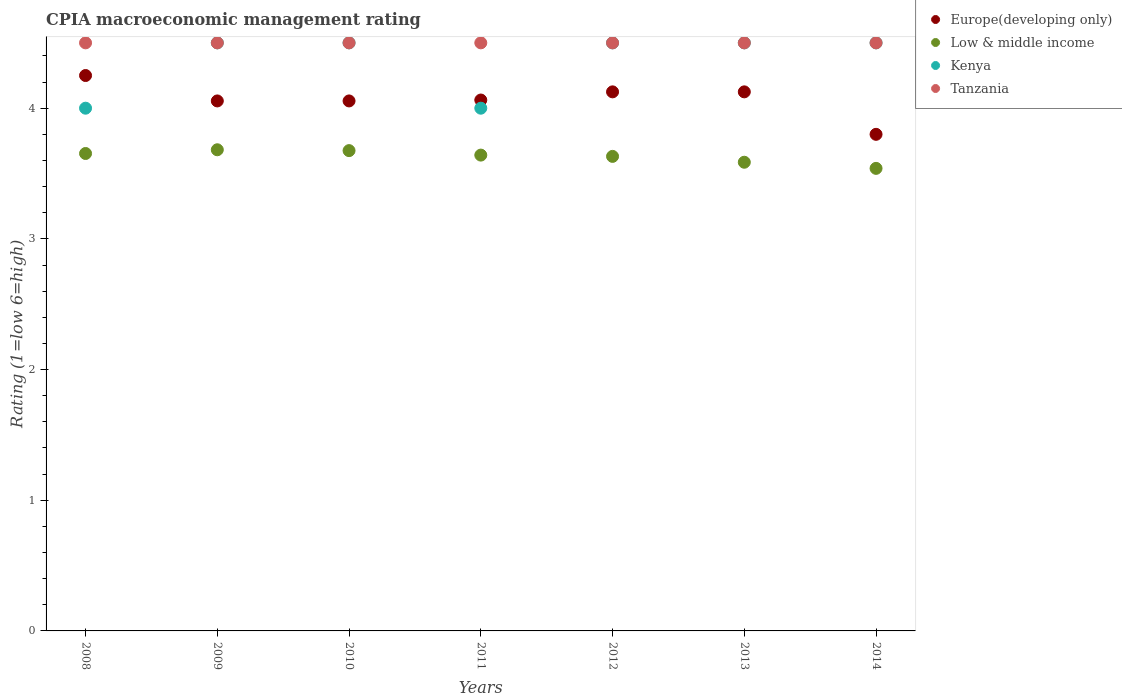What is the CPIA rating in Low & middle income in 2014?
Provide a succinct answer. 3.54. Across all years, what is the maximum CPIA rating in Europe(developing only)?
Offer a terse response. 4.25. In which year was the CPIA rating in Europe(developing only) minimum?
Keep it short and to the point. 2014. What is the total CPIA rating in Low & middle income in the graph?
Give a very brief answer. 25.41. What is the difference between the CPIA rating in Europe(developing only) in 2009 and that in 2014?
Give a very brief answer. 0.26. What is the difference between the CPIA rating in Low & middle income in 2011 and the CPIA rating in Kenya in 2008?
Keep it short and to the point. -0.36. What is the average CPIA rating in Low & middle income per year?
Keep it short and to the point. 3.63. In the year 2009, what is the difference between the CPIA rating in Europe(developing only) and CPIA rating in Kenya?
Provide a succinct answer. -0.44. In how many years, is the CPIA rating in Low & middle income greater than 1?
Your answer should be very brief. 7. What is the ratio of the CPIA rating in Tanzania in 2008 to that in 2010?
Give a very brief answer. 1. Is the difference between the CPIA rating in Europe(developing only) in 2013 and 2014 greater than the difference between the CPIA rating in Kenya in 2013 and 2014?
Your answer should be very brief. Yes. What is the difference between the highest and the second highest CPIA rating in Kenya?
Offer a terse response. 0. What is the difference between the highest and the lowest CPIA rating in Low & middle income?
Ensure brevity in your answer.  0.14. Is it the case that in every year, the sum of the CPIA rating in Kenya and CPIA rating in Europe(developing only)  is greater than the sum of CPIA rating in Tanzania and CPIA rating in Low & middle income?
Keep it short and to the point. No. Is it the case that in every year, the sum of the CPIA rating in Kenya and CPIA rating in Tanzania  is greater than the CPIA rating in Low & middle income?
Provide a short and direct response. Yes. Is the CPIA rating in Kenya strictly greater than the CPIA rating in Low & middle income over the years?
Provide a short and direct response. Yes. Is the CPIA rating in Tanzania strictly less than the CPIA rating in Low & middle income over the years?
Your response must be concise. No. What is the difference between two consecutive major ticks on the Y-axis?
Give a very brief answer. 1. Does the graph contain any zero values?
Your answer should be very brief. No. Does the graph contain grids?
Give a very brief answer. No. Where does the legend appear in the graph?
Keep it short and to the point. Top right. How many legend labels are there?
Give a very brief answer. 4. How are the legend labels stacked?
Provide a succinct answer. Vertical. What is the title of the graph?
Offer a terse response. CPIA macroeconomic management rating. Does "Cambodia" appear as one of the legend labels in the graph?
Give a very brief answer. No. What is the Rating (1=low 6=high) of Europe(developing only) in 2008?
Give a very brief answer. 4.25. What is the Rating (1=low 6=high) in Low & middle income in 2008?
Your answer should be compact. 3.65. What is the Rating (1=low 6=high) in Kenya in 2008?
Offer a terse response. 4. What is the Rating (1=low 6=high) of Europe(developing only) in 2009?
Make the answer very short. 4.06. What is the Rating (1=low 6=high) in Low & middle income in 2009?
Make the answer very short. 3.68. What is the Rating (1=low 6=high) of Kenya in 2009?
Keep it short and to the point. 4.5. What is the Rating (1=low 6=high) in Europe(developing only) in 2010?
Your answer should be very brief. 4.06. What is the Rating (1=low 6=high) of Low & middle income in 2010?
Offer a very short reply. 3.68. What is the Rating (1=low 6=high) of Europe(developing only) in 2011?
Your response must be concise. 4.06. What is the Rating (1=low 6=high) in Low & middle income in 2011?
Provide a succinct answer. 3.64. What is the Rating (1=low 6=high) in Kenya in 2011?
Your response must be concise. 4. What is the Rating (1=low 6=high) of Europe(developing only) in 2012?
Offer a very short reply. 4.12. What is the Rating (1=low 6=high) of Low & middle income in 2012?
Offer a very short reply. 3.63. What is the Rating (1=low 6=high) in Kenya in 2012?
Your answer should be very brief. 4.5. What is the Rating (1=low 6=high) of Tanzania in 2012?
Your answer should be very brief. 4.5. What is the Rating (1=low 6=high) in Europe(developing only) in 2013?
Your answer should be compact. 4.12. What is the Rating (1=low 6=high) in Low & middle income in 2013?
Your response must be concise. 3.59. What is the Rating (1=low 6=high) of Tanzania in 2013?
Your answer should be very brief. 4.5. What is the Rating (1=low 6=high) in Europe(developing only) in 2014?
Your answer should be compact. 3.8. What is the Rating (1=low 6=high) of Low & middle income in 2014?
Offer a terse response. 3.54. What is the Rating (1=low 6=high) of Kenya in 2014?
Provide a short and direct response. 4.5. What is the Rating (1=low 6=high) of Tanzania in 2014?
Make the answer very short. 4.5. Across all years, what is the maximum Rating (1=low 6=high) in Europe(developing only)?
Provide a short and direct response. 4.25. Across all years, what is the maximum Rating (1=low 6=high) in Low & middle income?
Give a very brief answer. 3.68. Across all years, what is the maximum Rating (1=low 6=high) in Tanzania?
Make the answer very short. 4.5. Across all years, what is the minimum Rating (1=low 6=high) of Low & middle income?
Provide a short and direct response. 3.54. Across all years, what is the minimum Rating (1=low 6=high) of Tanzania?
Give a very brief answer. 4.5. What is the total Rating (1=low 6=high) of Europe(developing only) in the graph?
Make the answer very short. 28.47. What is the total Rating (1=low 6=high) of Low & middle income in the graph?
Provide a succinct answer. 25.41. What is the total Rating (1=low 6=high) in Kenya in the graph?
Give a very brief answer. 30.5. What is the total Rating (1=low 6=high) in Tanzania in the graph?
Provide a short and direct response. 31.5. What is the difference between the Rating (1=low 6=high) of Europe(developing only) in 2008 and that in 2009?
Offer a very short reply. 0.19. What is the difference between the Rating (1=low 6=high) in Low & middle income in 2008 and that in 2009?
Offer a very short reply. -0.03. What is the difference between the Rating (1=low 6=high) of Europe(developing only) in 2008 and that in 2010?
Keep it short and to the point. 0.19. What is the difference between the Rating (1=low 6=high) in Low & middle income in 2008 and that in 2010?
Your response must be concise. -0.02. What is the difference between the Rating (1=low 6=high) of Kenya in 2008 and that in 2010?
Your answer should be compact. -0.5. What is the difference between the Rating (1=low 6=high) of Tanzania in 2008 and that in 2010?
Give a very brief answer. 0. What is the difference between the Rating (1=low 6=high) of Europe(developing only) in 2008 and that in 2011?
Offer a terse response. 0.19. What is the difference between the Rating (1=low 6=high) of Low & middle income in 2008 and that in 2011?
Keep it short and to the point. 0.01. What is the difference between the Rating (1=low 6=high) of Kenya in 2008 and that in 2011?
Your answer should be very brief. 0. What is the difference between the Rating (1=low 6=high) in Europe(developing only) in 2008 and that in 2012?
Keep it short and to the point. 0.12. What is the difference between the Rating (1=low 6=high) of Low & middle income in 2008 and that in 2012?
Your answer should be very brief. 0.02. What is the difference between the Rating (1=low 6=high) of Kenya in 2008 and that in 2012?
Offer a very short reply. -0.5. What is the difference between the Rating (1=low 6=high) in Europe(developing only) in 2008 and that in 2013?
Ensure brevity in your answer.  0.12. What is the difference between the Rating (1=low 6=high) of Low & middle income in 2008 and that in 2013?
Offer a terse response. 0.07. What is the difference between the Rating (1=low 6=high) of Europe(developing only) in 2008 and that in 2014?
Your response must be concise. 0.45. What is the difference between the Rating (1=low 6=high) in Low & middle income in 2008 and that in 2014?
Offer a terse response. 0.11. What is the difference between the Rating (1=low 6=high) in Kenya in 2008 and that in 2014?
Offer a terse response. -0.5. What is the difference between the Rating (1=low 6=high) of Europe(developing only) in 2009 and that in 2010?
Your answer should be very brief. 0. What is the difference between the Rating (1=low 6=high) of Low & middle income in 2009 and that in 2010?
Offer a terse response. 0.01. What is the difference between the Rating (1=low 6=high) of Kenya in 2009 and that in 2010?
Provide a short and direct response. 0. What is the difference between the Rating (1=low 6=high) of Europe(developing only) in 2009 and that in 2011?
Make the answer very short. -0.01. What is the difference between the Rating (1=low 6=high) in Low & middle income in 2009 and that in 2011?
Your response must be concise. 0.04. What is the difference between the Rating (1=low 6=high) of Kenya in 2009 and that in 2011?
Provide a short and direct response. 0.5. What is the difference between the Rating (1=low 6=high) of Tanzania in 2009 and that in 2011?
Provide a succinct answer. 0. What is the difference between the Rating (1=low 6=high) in Europe(developing only) in 2009 and that in 2012?
Ensure brevity in your answer.  -0.07. What is the difference between the Rating (1=low 6=high) of Low & middle income in 2009 and that in 2012?
Give a very brief answer. 0.05. What is the difference between the Rating (1=low 6=high) in Europe(developing only) in 2009 and that in 2013?
Your answer should be very brief. -0.07. What is the difference between the Rating (1=low 6=high) in Low & middle income in 2009 and that in 2013?
Provide a short and direct response. 0.1. What is the difference between the Rating (1=low 6=high) of Europe(developing only) in 2009 and that in 2014?
Keep it short and to the point. 0.26. What is the difference between the Rating (1=low 6=high) in Low & middle income in 2009 and that in 2014?
Keep it short and to the point. 0.14. What is the difference between the Rating (1=low 6=high) of Europe(developing only) in 2010 and that in 2011?
Your response must be concise. -0.01. What is the difference between the Rating (1=low 6=high) in Low & middle income in 2010 and that in 2011?
Your answer should be compact. 0.03. What is the difference between the Rating (1=low 6=high) in Europe(developing only) in 2010 and that in 2012?
Give a very brief answer. -0.07. What is the difference between the Rating (1=low 6=high) of Low & middle income in 2010 and that in 2012?
Your answer should be compact. 0.04. What is the difference between the Rating (1=low 6=high) in Tanzania in 2010 and that in 2012?
Offer a terse response. 0. What is the difference between the Rating (1=low 6=high) of Europe(developing only) in 2010 and that in 2013?
Offer a very short reply. -0.07. What is the difference between the Rating (1=low 6=high) of Low & middle income in 2010 and that in 2013?
Provide a succinct answer. 0.09. What is the difference between the Rating (1=low 6=high) in Kenya in 2010 and that in 2013?
Give a very brief answer. 0. What is the difference between the Rating (1=low 6=high) in Tanzania in 2010 and that in 2013?
Keep it short and to the point. 0. What is the difference between the Rating (1=low 6=high) of Europe(developing only) in 2010 and that in 2014?
Provide a short and direct response. 0.26. What is the difference between the Rating (1=low 6=high) of Low & middle income in 2010 and that in 2014?
Keep it short and to the point. 0.14. What is the difference between the Rating (1=low 6=high) of Tanzania in 2010 and that in 2014?
Ensure brevity in your answer.  0. What is the difference between the Rating (1=low 6=high) in Europe(developing only) in 2011 and that in 2012?
Provide a short and direct response. -0.06. What is the difference between the Rating (1=low 6=high) in Low & middle income in 2011 and that in 2012?
Provide a short and direct response. 0.01. What is the difference between the Rating (1=low 6=high) in Tanzania in 2011 and that in 2012?
Ensure brevity in your answer.  0. What is the difference between the Rating (1=low 6=high) of Europe(developing only) in 2011 and that in 2013?
Offer a very short reply. -0.06. What is the difference between the Rating (1=low 6=high) of Low & middle income in 2011 and that in 2013?
Provide a short and direct response. 0.05. What is the difference between the Rating (1=low 6=high) of Europe(developing only) in 2011 and that in 2014?
Ensure brevity in your answer.  0.26. What is the difference between the Rating (1=low 6=high) of Low & middle income in 2011 and that in 2014?
Make the answer very short. 0.1. What is the difference between the Rating (1=low 6=high) of Kenya in 2011 and that in 2014?
Provide a succinct answer. -0.5. What is the difference between the Rating (1=low 6=high) in Tanzania in 2011 and that in 2014?
Provide a short and direct response. 0. What is the difference between the Rating (1=low 6=high) in Low & middle income in 2012 and that in 2013?
Your answer should be compact. 0.04. What is the difference between the Rating (1=low 6=high) in Kenya in 2012 and that in 2013?
Ensure brevity in your answer.  0. What is the difference between the Rating (1=low 6=high) of Tanzania in 2012 and that in 2013?
Make the answer very short. 0. What is the difference between the Rating (1=low 6=high) of Europe(developing only) in 2012 and that in 2014?
Your response must be concise. 0.33. What is the difference between the Rating (1=low 6=high) of Low & middle income in 2012 and that in 2014?
Provide a succinct answer. 0.09. What is the difference between the Rating (1=low 6=high) of Kenya in 2012 and that in 2014?
Offer a terse response. 0. What is the difference between the Rating (1=low 6=high) in Tanzania in 2012 and that in 2014?
Make the answer very short. 0. What is the difference between the Rating (1=low 6=high) in Europe(developing only) in 2013 and that in 2014?
Provide a succinct answer. 0.33. What is the difference between the Rating (1=low 6=high) of Low & middle income in 2013 and that in 2014?
Offer a terse response. 0.05. What is the difference between the Rating (1=low 6=high) of Kenya in 2013 and that in 2014?
Make the answer very short. 0. What is the difference between the Rating (1=low 6=high) in Tanzania in 2013 and that in 2014?
Provide a succinct answer. 0. What is the difference between the Rating (1=low 6=high) of Europe(developing only) in 2008 and the Rating (1=low 6=high) of Low & middle income in 2009?
Keep it short and to the point. 0.57. What is the difference between the Rating (1=low 6=high) of Europe(developing only) in 2008 and the Rating (1=low 6=high) of Kenya in 2009?
Ensure brevity in your answer.  -0.25. What is the difference between the Rating (1=low 6=high) of Europe(developing only) in 2008 and the Rating (1=low 6=high) of Tanzania in 2009?
Offer a terse response. -0.25. What is the difference between the Rating (1=low 6=high) in Low & middle income in 2008 and the Rating (1=low 6=high) in Kenya in 2009?
Make the answer very short. -0.85. What is the difference between the Rating (1=low 6=high) of Low & middle income in 2008 and the Rating (1=low 6=high) of Tanzania in 2009?
Provide a succinct answer. -0.85. What is the difference between the Rating (1=low 6=high) of Kenya in 2008 and the Rating (1=low 6=high) of Tanzania in 2009?
Provide a short and direct response. -0.5. What is the difference between the Rating (1=low 6=high) in Europe(developing only) in 2008 and the Rating (1=low 6=high) in Low & middle income in 2010?
Your answer should be very brief. 0.57. What is the difference between the Rating (1=low 6=high) in Europe(developing only) in 2008 and the Rating (1=low 6=high) in Tanzania in 2010?
Offer a terse response. -0.25. What is the difference between the Rating (1=low 6=high) of Low & middle income in 2008 and the Rating (1=low 6=high) of Kenya in 2010?
Provide a short and direct response. -0.85. What is the difference between the Rating (1=low 6=high) in Low & middle income in 2008 and the Rating (1=low 6=high) in Tanzania in 2010?
Your answer should be compact. -0.85. What is the difference between the Rating (1=low 6=high) in Kenya in 2008 and the Rating (1=low 6=high) in Tanzania in 2010?
Your answer should be very brief. -0.5. What is the difference between the Rating (1=low 6=high) of Europe(developing only) in 2008 and the Rating (1=low 6=high) of Low & middle income in 2011?
Give a very brief answer. 0.61. What is the difference between the Rating (1=low 6=high) of Europe(developing only) in 2008 and the Rating (1=low 6=high) of Tanzania in 2011?
Provide a succinct answer. -0.25. What is the difference between the Rating (1=low 6=high) in Low & middle income in 2008 and the Rating (1=low 6=high) in Kenya in 2011?
Offer a terse response. -0.35. What is the difference between the Rating (1=low 6=high) in Low & middle income in 2008 and the Rating (1=low 6=high) in Tanzania in 2011?
Give a very brief answer. -0.85. What is the difference between the Rating (1=low 6=high) of Europe(developing only) in 2008 and the Rating (1=low 6=high) of Low & middle income in 2012?
Offer a very short reply. 0.62. What is the difference between the Rating (1=low 6=high) of Europe(developing only) in 2008 and the Rating (1=low 6=high) of Tanzania in 2012?
Offer a very short reply. -0.25. What is the difference between the Rating (1=low 6=high) of Low & middle income in 2008 and the Rating (1=low 6=high) of Kenya in 2012?
Provide a succinct answer. -0.85. What is the difference between the Rating (1=low 6=high) in Low & middle income in 2008 and the Rating (1=low 6=high) in Tanzania in 2012?
Offer a terse response. -0.85. What is the difference between the Rating (1=low 6=high) of Kenya in 2008 and the Rating (1=low 6=high) of Tanzania in 2012?
Provide a succinct answer. -0.5. What is the difference between the Rating (1=low 6=high) of Europe(developing only) in 2008 and the Rating (1=low 6=high) of Low & middle income in 2013?
Ensure brevity in your answer.  0.66. What is the difference between the Rating (1=low 6=high) of Low & middle income in 2008 and the Rating (1=low 6=high) of Kenya in 2013?
Keep it short and to the point. -0.85. What is the difference between the Rating (1=low 6=high) of Low & middle income in 2008 and the Rating (1=low 6=high) of Tanzania in 2013?
Provide a succinct answer. -0.85. What is the difference between the Rating (1=low 6=high) of Europe(developing only) in 2008 and the Rating (1=low 6=high) of Low & middle income in 2014?
Provide a succinct answer. 0.71. What is the difference between the Rating (1=low 6=high) of Europe(developing only) in 2008 and the Rating (1=low 6=high) of Tanzania in 2014?
Give a very brief answer. -0.25. What is the difference between the Rating (1=low 6=high) of Low & middle income in 2008 and the Rating (1=low 6=high) of Kenya in 2014?
Provide a succinct answer. -0.85. What is the difference between the Rating (1=low 6=high) of Low & middle income in 2008 and the Rating (1=low 6=high) of Tanzania in 2014?
Offer a very short reply. -0.85. What is the difference between the Rating (1=low 6=high) in Kenya in 2008 and the Rating (1=low 6=high) in Tanzania in 2014?
Your response must be concise. -0.5. What is the difference between the Rating (1=low 6=high) in Europe(developing only) in 2009 and the Rating (1=low 6=high) in Low & middle income in 2010?
Your response must be concise. 0.38. What is the difference between the Rating (1=low 6=high) in Europe(developing only) in 2009 and the Rating (1=low 6=high) in Kenya in 2010?
Keep it short and to the point. -0.44. What is the difference between the Rating (1=low 6=high) of Europe(developing only) in 2009 and the Rating (1=low 6=high) of Tanzania in 2010?
Make the answer very short. -0.44. What is the difference between the Rating (1=low 6=high) in Low & middle income in 2009 and the Rating (1=low 6=high) in Kenya in 2010?
Provide a succinct answer. -0.82. What is the difference between the Rating (1=low 6=high) in Low & middle income in 2009 and the Rating (1=low 6=high) in Tanzania in 2010?
Offer a very short reply. -0.82. What is the difference between the Rating (1=low 6=high) of Europe(developing only) in 2009 and the Rating (1=low 6=high) of Low & middle income in 2011?
Your response must be concise. 0.41. What is the difference between the Rating (1=low 6=high) in Europe(developing only) in 2009 and the Rating (1=low 6=high) in Kenya in 2011?
Your answer should be compact. 0.06. What is the difference between the Rating (1=low 6=high) of Europe(developing only) in 2009 and the Rating (1=low 6=high) of Tanzania in 2011?
Your answer should be very brief. -0.44. What is the difference between the Rating (1=low 6=high) of Low & middle income in 2009 and the Rating (1=low 6=high) of Kenya in 2011?
Your answer should be compact. -0.32. What is the difference between the Rating (1=low 6=high) in Low & middle income in 2009 and the Rating (1=low 6=high) in Tanzania in 2011?
Keep it short and to the point. -0.82. What is the difference between the Rating (1=low 6=high) of Europe(developing only) in 2009 and the Rating (1=low 6=high) of Low & middle income in 2012?
Provide a short and direct response. 0.42. What is the difference between the Rating (1=low 6=high) in Europe(developing only) in 2009 and the Rating (1=low 6=high) in Kenya in 2012?
Your answer should be compact. -0.44. What is the difference between the Rating (1=low 6=high) in Europe(developing only) in 2009 and the Rating (1=low 6=high) in Tanzania in 2012?
Provide a short and direct response. -0.44. What is the difference between the Rating (1=low 6=high) of Low & middle income in 2009 and the Rating (1=low 6=high) of Kenya in 2012?
Your response must be concise. -0.82. What is the difference between the Rating (1=low 6=high) of Low & middle income in 2009 and the Rating (1=low 6=high) of Tanzania in 2012?
Make the answer very short. -0.82. What is the difference between the Rating (1=low 6=high) of Kenya in 2009 and the Rating (1=low 6=high) of Tanzania in 2012?
Your answer should be very brief. 0. What is the difference between the Rating (1=low 6=high) of Europe(developing only) in 2009 and the Rating (1=low 6=high) of Low & middle income in 2013?
Give a very brief answer. 0.47. What is the difference between the Rating (1=low 6=high) of Europe(developing only) in 2009 and the Rating (1=low 6=high) of Kenya in 2013?
Your answer should be compact. -0.44. What is the difference between the Rating (1=low 6=high) of Europe(developing only) in 2009 and the Rating (1=low 6=high) of Tanzania in 2013?
Give a very brief answer. -0.44. What is the difference between the Rating (1=low 6=high) of Low & middle income in 2009 and the Rating (1=low 6=high) of Kenya in 2013?
Your answer should be very brief. -0.82. What is the difference between the Rating (1=low 6=high) of Low & middle income in 2009 and the Rating (1=low 6=high) of Tanzania in 2013?
Make the answer very short. -0.82. What is the difference between the Rating (1=low 6=high) of Kenya in 2009 and the Rating (1=low 6=high) of Tanzania in 2013?
Your answer should be compact. 0. What is the difference between the Rating (1=low 6=high) of Europe(developing only) in 2009 and the Rating (1=low 6=high) of Low & middle income in 2014?
Your answer should be very brief. 0.52. What is the difference between the Rating (1=low 6=high) of Europe(developing only) in 2009 and the Rating (1=low 6=high) of Kenya in 2014?
Offer a very short reply. -0.44. What is the difference between the Rating (1=low 6=high) in Europe(developing only) in 2009 and the Rating (1=low 6=high) in Tanzania in 2014?
Provide a succinct answer. -0.44. What is the difference between the Rating (1=low 6=high) of Low & middle income in 2009 and the Rating (1=low 6=high) of Kenya in 2014?
Your response must be concise. -0.82. What is the difference between the Rating (1=low 6=high) of Low & middle income in 2009 and the Rating (1=low 6=high) of Tanzania in 2014?
Offer a terse response. -0.82. What is the difference between the Rating (1=low 6=high) in Kenya in 2009 and the Rating (1=low 6=high) in Tanzania in 2014?
Offer a very short reply. 0. What is the difference between the Rating (1=low 6=high) of Europe(developing only) in 2010 and the Rating (1=low 6=high) of Low & middle income in 2011?
Your response must be concise. 0.41. What is the difference between the Rating (1=low 6=high) in Europe(developing only) in 2010 and the Rating (1=low 6=high) in Kenya in 2011?
Offer a terse response. 0.06. What is the difference between the Rating (1=low 6=high) of Europe(developing only) in 2010 and the Rating (1=low 6=high) of Tanzania in 2011?
Offer a terse response. -0.44. What is the difference between the Rating (1=low 6=high) in Low & middle income in 2010 and the Rating (1=low 6=high) in Kenya in 2011?
Give a very brief answer. -0.32. What is the difference between the Rating (1=low 6=high) of Low & middle income in 2010 and the Rating (1=low 6=high) of Tanzania in 2011?
Keep it short and to the point. -0.82. What is the difference between the Rating (1=low 6=high) in Kenya in 2010 and the Rating (1=low 6=high) in Tanzania in 2011?
Provide a short and direct response. 0. What is the difference between the Rating (1=low 6=high) in Europe(developing only) in 2010 and the Rating (1=low 6=high) in Low & middle income in 2012?
Make the answer very short. 0.42. What is the difference between the Rating (1=low 6=high) in Europe(developing only) in 2010 and the Rating (1=low 6=high) in Kenya in 2012?
Your answer should be compact. -0.44. What is the difference between the Rating (1=low 6=high) in Europe(developing only) in 2010 and the Rating (1=low 6=high) in Tanzania in 2012?
Your response must be concise. -0.44. What is the difference between the Rating (1=low 6=high) of Low & middle income in 2010 and the Rating (1=low 6=high) of Kenya in 2012?
Your response must be concise. -0.82. What is the difference between the Rating (1=low 6=high) of Low & middle income in 2010 and the Rating (1=low 6=high) of Tanzania in 2012?
Make the answer very short. -0.82. What is the difference between the Rating (1=low 6=high) of Europe(developing only) in 2010 and the Rating (1=low 6=high) of Low & middle income in 2013?
Offer a very short reply. 0.47. What is the difference between the Rating (1=low 6=high) of Europe(developing only) in 2010 and the Rating (1=low 6=high) of Kenya in 2013?
Keep it short and to the point. -0.44. What is the difference between the Rating (1=low 6=high) of Europe(developing only) in 2010 and the Rating (1=low 6=high) of Tanzania in 2013?
Make the answer very short. -0.44. What is the difference between the Rating (1=low 6=high) in Low & middle income in 2010 and the Rating (1=low 6=high) in Kenya in 2013?
Offer a terse response. -0.82. What is the difference between the Rating (1=low 6=high) in Low & middle income in 2010 and the Rating (1=low 6=high) in Tanzania in 2013?
Keep it short and to the point. -0.82. What is the difference between the Rating (1=low 6=high) of Europe(developing only) in 2010 and the Rating (1=low 6=high) of Low & middle income in 2014?
Offer a terse response. 0.52. What is the difference between the Rating (1=low 6=high) in Europe(developing only) in 2010 and the Rating (1=low 6=high) in Kenya in 2014?
Your answer should be very brief. -0.44. What is the difference between the Rating (1=low 6=high) in Europe(developing only) in 2010 and the Rating (1=low 6=high) in Tanzania in 2014?
Your response must be concise. -0.44. What is the difference between the Rating (1=low 6=high) in Low & middle income in 2010 and the Rating (1=low 6=high) in Kenya in 2014?
Your answer should be very brief. -0.82. What is the difference between the Rating (1=low 6=high) in Low & middle income in 2010 and the Rating (1=low 6=high) in Tanzania in 2014?
Your response must be concise. -0.82. What is the difference between the Rating (1=low 6=high) in Europe(developing only) in 2011 and the Rating (1=low 6=high) in Low & middle income in 2012?
Keep it short and to the point. 0.43. What is the difference between the Rating (1=low 6=high) in Europe(developing only) in 2011 and the Rating (1=low 6=high) in Kenya in 2012?
Keep it short and to the point. -0.44. What is the difference between the Rating (1=low 6=high) of Europe(developing only) in 2011 and the Rating (1=low 6=high) of Tanzania in 2012?
Provide a succinct answer. -0.44. What is the difference between the Rating (1=low 6=high) in Low & middle income in 2011 and the Rating (1=low 6=high) in Kenya in 2012?
Provide a succinct answer. -0.86. What is the difference between the Rating (1=low 6=high) in Low & middle income in 2011 and the Rating (1=low 6=high) in Tanzania in 2012?
Your response must be concise. -0.86. What is the difference between the Rating (1=low 6=high) in Kenya in 2011 and the Rating (1=low 6=high) in Tanzania in 2012?
Provide a succinct answer. -0.5. What is the difference between the Rating (1=low 6=high) of Europe(developing only) in 2011 and the Rating (1=low 6=high) of Low & middle income in 2013?
Ensure brevity in your answer.  0.48. What is the difference between the Rating (1=low 6=high) of Europe(developing only) in 2011 and the Rating (1=low 6=high) of Kenya in 2013?
Your response must be concise. -0.44. What is the difference between the Rating (1=low 6=high) in Europe(developing only) in 2011 and the Rating (1=low 6=high) in Tanzania in 2013?
Provide a succinct answer. -0.44. What is the difference between the Rating (1=low 6=high) of Low & middle income in 2011 and the Rating (1=low 6=high) of Kenya in 2013?
Make the answer very short. -0.86. What is the difference between the Rating (1=low 6=high) of Low & middle income in 2011 and the Rating (1=low 6=high) of Tanzania in 2013?
Provide a short and direct response. -0.86. What is the difference between the Rating (1=low 6=high) of Europe(developing only) in 2011 and the Rating (1=low 6=high) of Low & middle income in 2014?
Ensure brevity in your answer.  0.52. What is the difference between the Rating (1=low 6=high) of Europe(developing only) in 2011 and the Rating (1=low 6=high) of Kenya in 2014?
Ensure brevity in your answer.  -0.44. What is the difference between the Rating (1=low 6=high) of Europe(developing only) in 2011 and the Rating (1=low 6=high) of Tanzania in 2014?
Your answer should be very brief. -0.44. What is the difference between the Rating (1=low 6=high) of Low & middle income in 2011 and the Rating (1=low 6=high) of Kenya in 2014?
Offer a terse response. -0.86. What is the difference between the Rating (1=low 6=high) of Low & middle income in 2011 and the Rating (1=low 6=high) of Tanzania in 2014?
Make the answer very short. -0.86. What is the difference between the Rating (1=low 6=high) of Kenya in 2011 and the Rating (1=low 6=high) of Tanzania in 2014?
Ensure brevity in your answer.  -0.5. What is the difference between the Rating (1=low 6=high) in Europe(developing only) in 2012 and the Rating (1=low 6=high) in Low & middle income in 2013?
Provide a short and direct response. 0.54. What is the difference between the Rating (1=low 6=high) in Europe(developing only) in 2012 and the Rating (1=low 6=high) in Kenya in 2013?
Ensure brevity in your answer.  -0.38. What is the difference between the Rating (1=low 6=high) of Europe(developing only) in 2012 and the Rating (1=low 6=high) of Tanzania in 2013?
Your answer should be compact. -0.38. What is the difference between the Rating (1=low 6=high) in Low & middle income in 2012 and the Rating (1=low 6=high) in Kenya in 2013?
Your response must be concise. -0.87. What is the difference between the Rating (1=low 6=high) in Low & middle income in 2012 and the Rating (1=low 6=high) in Tanzania in 2013?
Make the answer very short. -0.87. What is the difference between the Rating (1=low 6=high) of Europe(developing only) in 2012 and the Rating (1=low 6=high) of Low & middle income in 2014?
Provide a succinct answer. 0.59. What is the difference between the Rating (1=low 6=high) in Europe(developing only) in 2012 and the Rating (1=low 6=high) in Kenya in 2014?
Your answer should be very brief. -0.38. What is the difference between the Rating (1=low 6=high) in Europe(developing only) in 2012 and the Rating (1=low 6=high) in Tanzania in 2014?
Your answer should be very brief. -0.38. What is the difference between the Rating (1=low 6=high) of Low & middle income in 2012 and the Rating (1=low 6=high) of Kenya in 2014?
Provide a succinct answer. -0.87. What is the difference between the Rating (1=low 6=high) in Low & middle income in 2012 and the Rating (1=low 6=high) in Tanzania in 2014?
Your response must be concise. -0.87. What is the difference between the Rating (1=low 6=high) of Kenya in 2012 and the Rating (1=low 6=high) of Tanzania in 2014?
Make the answer very short. 0. What is the difference between the Rating (1=low 6=high) in Europe(developing only) in 2013 and the Rating (1=low 6=high) in Low & middle income in 2014?
Give a very brief answer. 0.59. What is the difference between the Rating (1=low 6=high) of Europe(developing only) in 2013 and the Rating (1=low 6=high) of Kenya in 2014?
Provide a succinct answer. -0.38. What is the difference between the Rating (1=low 6=high) in Europe(developing only) in 2013 and the Rating (1=low 6=high) in Tanzania in 2014?
Your response must be concise. -0.38. What is the difference between the Rating (1=low 6=high) in Low & middle income in 2013 and the Rating (1=low 6=high) in Kenya in 2014?
Keep it short and to the point. -0.91. What is the difference between the Rating (1=low 6=high) of Low & middle income in 2013 and the Rating (1=low 6=high) of Tanzania in 2014?
Offer a very short reply. -0.91. What is the difference between the Rating (1=low 6=high) of Kenya in 2013 and the Rating (1=low 6=high) of Tanzania in 2014?
Offer a terse response. 0. What is the average Rating (1=low 6=high) of Europe(developing only) per year?
Offer a very short reply. 4.07. What is the average Rating (1=low 6=high) of Low & middle income per year?
Your answer should be very brief. 3.63. What is the average Rating (1=low 6=high) of Kenya per year?
Keep it short and to the point. 4.36. What is the average Rating (1=low 6=high) in Tanzania per year?
Offer a very short reply. 4.5. In the year 2008, what is the difference between the Rating (1=low 6=high) of Europe(developing only) and Rating (1=low 6=high) of Low & middle income?
Offer a terse response. 0.6. In the year 2008, what is the difference between the Rating (1=low 6=high) in Europe(developing only) and Rating (1=low 6=high) in Tanzania?
Offer a very short reply. -0.25. In the year 2008, what is the difference between the Rating (1=low 6=high) of Low & middle income and Rating (1=low 6=high) of Kenya?
Offer a terse response. -0.35. In the year 2008, what is the difference between the Rating (1=low 6=high) in Low & middle income and Rating (1=low 6=high) in Tanzania?
Your answer should be compact. -0.85. In the year 2009, what is the difference between the Rating (1=low 6=high) in Europe(developing only) and Rating (1=low 6=high) in Low & middle income?
Provide a succinct answer. 0.37. In the year 2009, what is the difference between the Rating (1=low 6=high) of Europe(developing only) and Rating (1=low 6=high) of Kenya?
Your response must be concise. -0.44. In the year 2009, what is the difference between the Rating (1=low 6=high) of Europe(developing only) and Rating (1=low 6=high) of Tanzania?
Keep it short and to the point. -0.44. In the year 2009, what is the difference between the Rating (1=low 6=high) of Low & middle income and Rating (1=low 6=high) of Kenya?
Ensure brevity in your answer.  -0.82. In the year 2009, what is the difference between the Rating (1=low 6=high) of Low & middle income and Rating (1=low 6=high) of Tanzania?
Offer a very short reply. -0.82. In the year 2009, what is the difference between the Rating (1=low 6=high) of Kenya and Rating (1=low 6=high) of Tanzania?
Offer a terse response. 0. In the year 2010, what is the difference between the Rating (1=low 6=high) of Europe(developing only) and Rating (1=low 6=high) of Low & middle income?
Make the answer very short. 0.38. In the year 2010, what is the difference between the Rating (1=low 6=high) in Europe(developing only) and Rating (1=low 6=high) in Kenya?
Provide a succinct answer. -0.44. In the year 2010, what is the difference between the Rating (1=low 6=high) in Europe(developing only) and Rating (1=low 6=high) in Tanzania?
Ensure brevity in your answer.  -0.44. In the year 2010, what is the difference between the Rating (1=low 6=high) in Low & middle income and Rating (1=low 6=high) in Kenya?
Provide a short and direct response. -0.82. In the year 2010, what is the difference between the Rating (1=low 6=high) in Low & middle income and Rating (1=low 6=high) in Tanzania?
Ensure brevity in your answer.  -0.82. In the year 2010, what is the difference between the Rating (1=low 6=high) of Kenya and Rating (1=low 6=high) of Tanzania?
Provide a succinct answer. 0. In the year 2011, what is the difference between the Rating (1=low 6=high) of Europe(developing only) and Rating (1=low 6=high) of Low & middle income?
Offer a terse response. 0.42. In the year 2011, what is the difference between the Rating (1=low 6=high) of Europe(developing only) and Rating (1=low 6=high) of Kenya?
Give a very brief answer. 0.06. In the year 2011, what is the difference between the Rating (1=low 6=high) of Europe(developing only) and Rating (1=low 6=high) of Tanzania?
Provide a short and direct response. -0.44. In the year 2011, what is the difference between the Rating (1=low 6=high) in Low & middle income and Rating (1=low 6=high) in Kenya?
Keep it short and to the point. -0.36. In the year 2011, what is the difference between the Rating (1=low 6=high) of Low & middle income and Rating (1=low 6=high) of Tanzania?
Ensure brevity in your answer.  -0.86. In the year 2011, what is the difference between the Rating (1=low 6=high) in Kenya and Rating (1=low 6=high) in Tanzania?
Offer a terse response. -0.5. In the year 2012, what is the difference between the Rating (1=low 6=high) of Europe(developing only) and Rating (1=low 6=high) of Low & middle income?
Give a very brief answer. 0.49. In the year 2012, what is the difference between the Rating (1=low 6=high) of Europe(developing only) and Rating (1=low 6=high) of Kenya?
Provide a short and direct response. -0.38. In the year 2012, what is the difference between the Rating (1=low 6=high) of Europe(developing only) and Rating (1=low 6=high) of Tanzania?
Your answer should be compact. -0.38. In the year 2012, what is the difference between the Rating (1=low 6=high) in Low & middle income and Rating (1=low 6=high) in Kenya?
Ensure brevity in your answer.  -0.87. In the year 2012, what is the difference between the Rating (1=low 6=high) of Low & middle income and Rating (1=low 6=high) of Tanzania?
Provide a short and direct response. -0.87. In the year 2012, what is the difference between the Rating (1=low 6=high) in Kenya and Rating (1=low 6=high) in Tanzania?
Provide a succinct answer. 0. In the year 2013, what is the difference between the Rating (1=low 6=high) of Europe(developing only) and Rating (1=low 6=high) of Low & middle income?
Make the answer very short. 0.54. In the year 2013, what is the difference between the Rating (1=low 6=high) in Europe(developing only) and Rating (1=low 6=high) in Kenya?
Provide a short and direct response. -0.38. In the year 2013, what is the difference between the Rating (1=low 6=high) in Europe(developing only) and Rating (1=low 6=high) in Tanzania?
Your answer should be very brief. -0.38. In the year 2013, what is the difference between the Rating (1=low 6=high) in Low & middle income and Rating (1=low 6=high) in Kenya?
Give a very brief answer. -0.91. In the year 2013, what is the difference between the Rating (1=low 6=high) of Low & middle income and Rating (1=low 6=high) of Tanzania?
Your answer should be compact. -0.91. In the year 2014, what is the difference between the Rating (1=low 6=high) of Europe(developing only) and Rating (1=low 6=high) of Low & middle income?
Keep it short and to the point. 0.26. In the year 2014, what is the difference between the Rating (1=low 6=high) of Low & middle income and Rating (1=low 6=high) of Kenya?
Make the answer very short. -0.96. In the year 2014, what is the difference between the Rating (1=low 6=high) of Low & middle income and Rating (1=low 6=high) of Tanzania?
Your answer should be very brief. -0.96. In the year 2014, what is the difference between the Rating (1=low 6=high) in Kenya and Rating (1=low 6=high) in Tanzania?
Provide a short and direct response. 0. What is the ratio of the Rating (1=low 6=high) of Europe(developing only) in 2008 to that in 2009?
Offer a terse response. 1.05. What is the ratio of the Rating (1=low 6=high) in Low & middle income in 2008 to that in 2009?
Provide a succinct answer. 0.99. What is the ratio of the Rating (1=low 6=high) in Kenya in 2008 to that in 2009?
Offer a terse response. 0.89. What is the ratio of the Rating (1=low 6=high) of Tanzania in 2008 to that in 2009?
Offer a terse response. 1. What is the ratio of the Rating (1=low 6=high) in Europe(developing only) in 2008 to that in 2010?
Give a very brief answer. 1.05. What is the ratio of the Rating (1=low 6=high) of Kenya in 2008 to that in 2010?
Offer a very short reply. 0.89. What is the ratio of the Rating (1=low 6=high) of Europe(developing only) in 2008 to that in 2011?
Your response must be concise. 1.05. What is the ratio of the Rating (1=low 6=high) in Tanzania in 2008 to that in 2011?
Your answer should be very brief. 1. What is the ratio of the Rating (1=low 6=high) in Europe(developing only) in 2008 to that in 2012?
Provide a short and direct response. 1.03. What is the ratio of the Rating (1=low 6=high) in Europe(developing only) in 2008 to that in 2013?
Ensure brevity in your answer.  1.03. What is the ratio of the Rating (1=low 6=high) in Low & middle income in 2008 to that in 2013?
Give a very brief answer. 1.02. What is the ratio of the Rating (1=low 6=high) in Kenya in 2008 to that in 2013?
Your answer should be compact. 0.89. What is the ratio of the Rating (1=low 6=high) in Europe(developing only) in 2008 to that in 2014?
Provide a short and direct response. 1.12. What is the ratio of the Rating (1=low 6=high) in Low & middle income in 2008 to that in 2014?
Ensure brevity in your answer.  1.03. What is the ratio of the Rating (1=low 6=high) in Kenya in 2008 to that in 2014?
Your answer should be compact. 0.89. What is the ratio of the Rating (1=low 6=high) of Kenya in 2009 to that in 2010?
Offer a terse response. 1. What is the ratio of the Rating (1=low 6=high) of Tanzania in 2009 to that in 2010?
Offer a very short reply. 1. What is the ratio of the Rating (1=low 6=high) of Europe(developing only) in 2009 to that in 2011?
Offer a very short reply. 1. What is the ratio of the Rating (1=low 6=high) in Low & middle income in 2009 to that in 2011?
Provide a short and direct response. 1.01. What is the ratio of the Rating (1=low 6=high) of Europe(developing only) in 2009 to that in 2012?
Your answer should be compact. 0.98. What is the ratio of the Rating (1=low 6=high) of Low & middle income in 2009 to that in 2012?
Ensure brevity in your answer.  1.01. What is the ratio of the Rating (1=low 6=high) in Europe(developing only) in 2009 to that in 2013?
Give a very brief answer. 0.98. What is the ratio of the Rating (1=low 6=high) in Low & middle income in 2009 to that in 2013?
Your response must be concise. 1.03. What is the ratio of the Rating (1=low 6=high) in Kenya in 2009 to that in 2013?
Your answer should be very brief. 1. What is the ratio of the Rating (1=low 6=high) in Europe(developing only) in 2009 to that in 2014?
Your response must be concise. 1.07. What is the ratio of the Rating (1=low 6=high) in Low & middle income in 2009 to that in 2014?
Provide a succinct answer. 1.04. What is the ratio of the Rating (1=low 6=high) of Kenya in 2009 to that in 2014?
Keep it short and to the point. 1. What is the ratio of the Rating (1=low 6=high) in Tanzania in 2009 to that in 2014?
Keep it short and to the point. 1. What is the ratio of the Rating (1=low 6=high) in Europe(developing only) in 2010 to that in 2011?
Provide a succinct answer. 1. What is the ratio of the Rating (1=low 6=high) in Low & middle income in 2010 to that in 2011?
Offer a terse response. 1.01. What is the ratio of the Rating (1=low 6=high) of Europe(developing only) in 2010 to that in 2012?
Offer a terse response. 0.98. What is the ratio of the Rating (1=low 6=high) of Low & middle income in 2010 to that in 2012?
Offer a terse response. 1.01. What is the ratio of the Rating (1=low 6=high) of Europe(developing only) in 2010 to that in 2013?
Give a very brief answer. 0.98. What is the ratio of the Rating (1=low 6=high) of Low & middle income in 2010 to that in 2013?
Ensure brevity in your answer.  1.02. What is the ratio of the Rating (1=low 6=high) in Kenya in 2010 to that in 2013?
Your response must be concise. 1. What is the ratio of the Rating (1=low 6=high) in Europe(developing only) in 2010 to that in 2014?
Your answer should be compact. 1.07. What is the ratio of the Rating (1=low 6=high) in Low & middle income in 2010 to that in 2014?
Offer a terse response. 1.04. What is the ratio of the Rating (1=low 6=high) in Europe(developing only) in 2011 to that in 2012?
Ensure brevity in your answer.  0.98. What is the ratio of the Rating (1=low 6=high) in Low & middle income in 2011 to that in 2012?
Give a very brief answer. 1. What is the ratio of the Rating (1=low 6=high) of Tanzania in 2011 to that in 2012?
Your response must be concise. 1. What is the ratio of the Rating (1=low 6=high) in Low & middle income in 2011 to that in 2013?
Your answer should be compact. 1.02. What is the ratio of the Rating (1=low 6=high) in Tanzania in 2011 to that in 2013?
Ensure brevity in your answer.  1. What is the ratio of the Rating (1=low 6=high) of Europe(developing only) in 2011 to that in 2014?
Your answer should be very brief. 1.07. What is the ratio of the Rating (1=low 6=high) in Low & middle income in 2011 to that in 2014?
Provide a succinct answer. 1.03. What is the ratio of the Rating (1=low 6=high) in Kenya in 2011 to that in 2014?
Make the answer very short. 0.89. What is the ratio of the Rating (1=low 6=high) in Tanzania in 2011 to that in 2014?
Offer a terse response. 1. What is the ratio of the Rating (1=low 6=high) of Europe(developing only) in 2012 to that in 2013?
Offer a very short reply. 1. What is the ratio of the Rating (1=low 6=high) in Low & middle income in 2012 to that in 2013?
Provide a short and direct response. 1.01. What is the ratio of the Rating (1=low 6=high) of Europe(developing only) in 2012 to that in 2014?
Provide a short and direct response. 1.09. What is the ratio of the Rating (1=low 6=high) in Low & middle income in 2012 to that in 2014?
Offer a very short reply. 1.03. What is the ratio of the Rating (1=low 6=high) of Kenya in 2012 to that in 2014?
Your response must be concise. 1. What is the ratio of the Rating (1=low 6=high) in Europe(developing only) in 2013 to that in 2014?
Your answer should be very brief. 1.09. What is the ratio of the Rating (1=low 6=high) of Low & middle income in 2013 to that in 2014?
Your answer should be compact. 1.01. What is the ratio of the Rating (1=low 6=high) of Kenya in 2013 to that in 2014?
Provide a short and direct response. 1. What is the difference between the highest and the second highest Rating (1=low 6=high) of Europe(developing only)?
Offer a terse response. 0.12. What is the difference between the highest and the second highest Rating (1=low 6=high) of Low & middle income?
Provide a short and direct response. 0.01. What is the difference between the highest and the second highest Rating (1=low 6=high) of Tanzania?
Provide a succinct answer. 0. What is the difference between the highest and the lowest Rating (1=low 6=high) of Europe(developing only)?
Provide a succinct answer. 0.45. What is the difference between the highest and the lowest Rating (1=low 6=high) of Low & middle income?
Make the answer very short. 0.14. 